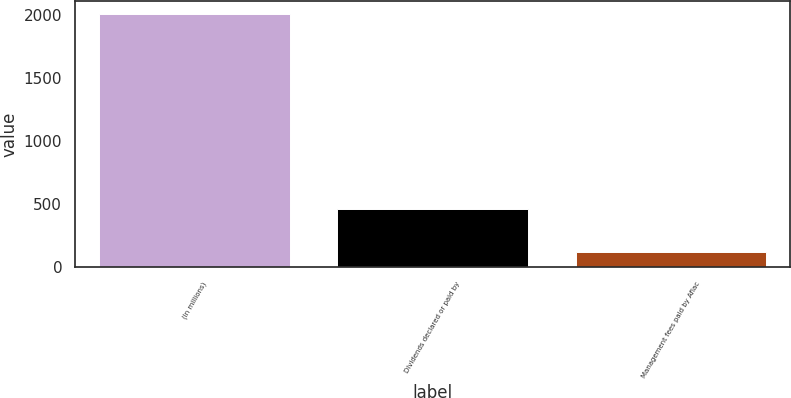Convert chart to OTSL. <chart><loc_0><loc_0><loc_500><loc_500><bar_chart><fcel>(In millions)<fcel>Dividends declared or paid by<fcel>Management fees paid by Aflac<nl><fcel>2009<fcel>464<fcel>124<nl></chart> 